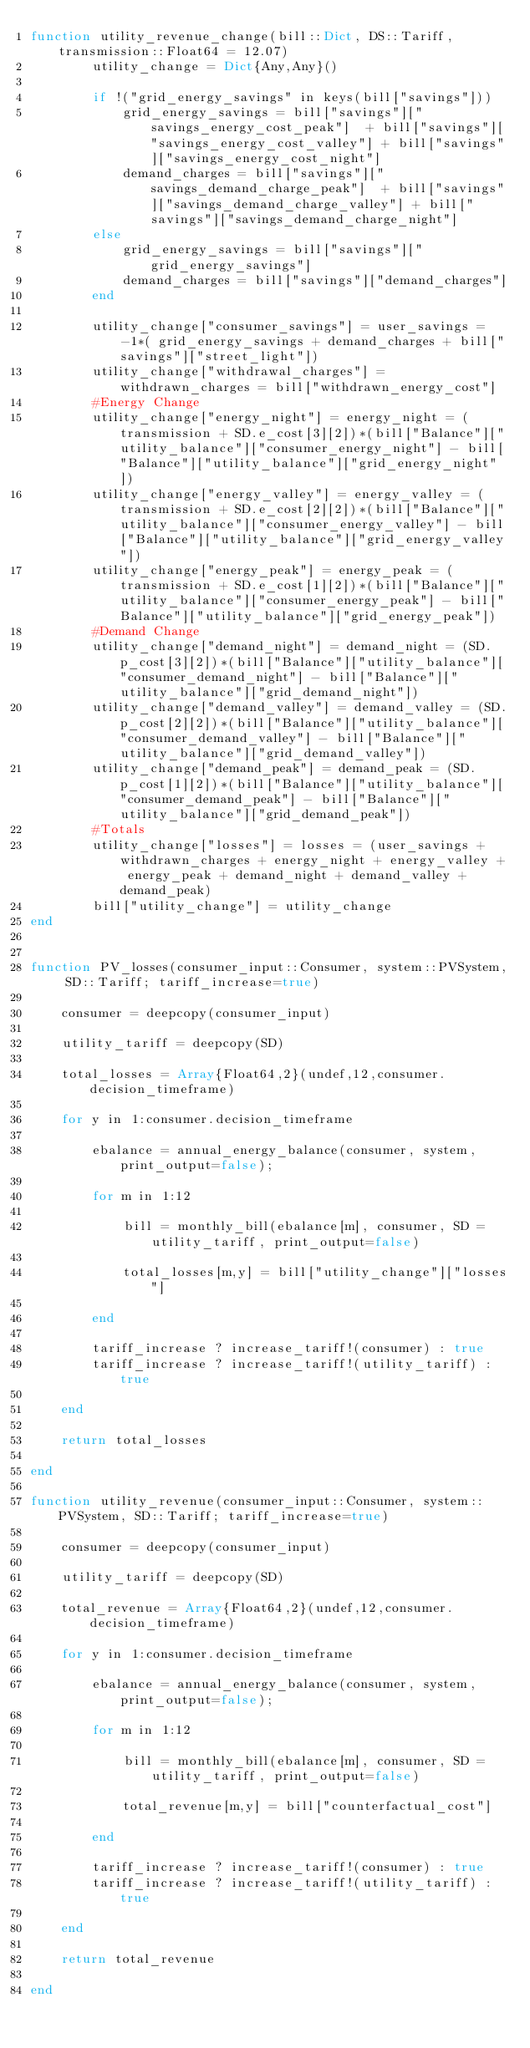<code> <loc_0><loc_0><loc_500><loc_500><_Julia_>function utility_revenue_change(bill::Dict, DS::Tariff, transmission::Float64 = 12.07)
        utility_change = Dict{Any,Any}()
        
		if !("grid_energy_savings" in keys(bill["savings"]))
			grid_energy_savings = bill["savings"]["savings_energy_cost_peak"]  + bill["savings"]["savings_energy_cost_valley"] + bill["savings"]["savings_energy_cost_night"]
		    demand_charges = bill["savings"]["savings_demand_charge_peak"]  + bill["savings"]["savings_demand_charge_valley"] + bill["savings"]["savings_demand_charge_night"]
		else
			grid_energy_savings = bill["savings"]["grid_energy_savings"]
			demand_charges = bill["savings"]["demand_charges"]
		end
		
		utility_change["consumer_savings"] = user_savings = -1*( grid_energy_savings + demand_charges + bill["savings"]["street_light"])
        utility_change["withdrawal_charges"] = withdrawn_charges = bill["withdrawn_energy_cost"]
        #Energy Change 
        utility_change["energy_night"] = energy_night = (transmission + SD.e_cost[3][2])*(bill["Balance"]["utility_balance"]["consumer_energy_night"] - bill["Balance"]["utility_balance"]["grid_energy_night"])
        utility_change["energy_valley"] = energy_valley = (transmission + SD.e_cost[2][2])*(bill["Balance"]["utility_balance"]["consumer_energy_valley"] - bill["Balance"]["utility_balance"]["grid_energy_valley"])
        utility_change["energy_peak"] = energy_peak = (transmission + SD.e_cost[1][2])*(bill["Balance"]["utility_balance"]["consumer_energy_peak"] - bill["Balance"]["utility_balance"]["grid_energy_peak"])
        #Demand Change 
        utility_change["demand_night"] = demand_night = (SD.p_cost[3][2])*(bill["Balance"]["utility_balance"]["consumer_demand_night"] - bill["Balance"]["utility_balance"]["grid_demand_night"])
        utility_change["demand_valley"] = demand_valley = (SD.p_cost[2][2])*(bill["Balance"]["utility_balance"]["consumer_demand_valley"] - bill["Balance"]["utility_balance"]["grid_demand_valley"])
        utility_change["demand_peak"] = demand_peak = (SD.p_cost[1][2])*(bill["Balance"]["utility_balance"]["consumer_demand_peak"] - bill["Balance"]["utility_balance"]["grid_demand_peak"])      
        #Totals
        utility_change["losses"] = losses = (user_savings + withdrawn_charges + energy_night + energy_valley + energy_peak + demand_night + demand_valley + demand_peak) 
        bill["utility_change"] = utility_change
end
	
	
function PV_losses(consumer_input::Consumer, system::PVSystem, SD::Tariff; tariff_increase=true)
    
    consumer = deepcopy(consumer_input)
    
	utility_tariff = deepcopy(SD)	
		
	total_losses = Array{Float64,2}(undef,12,consumer.decision_timeframe)
    
    for y in 1:consumer.decision_timeframe
                
        ebalance = annual_energy_balance(consumer, system, print_output=false);
        
        for m in 1:12

            bill = monthly_bill(ebalance[m], consumer, SD = utility_tariff, print_output=false)

            total_losses[m,y] = bill["utility_change"]["losses"]

        end
        
        tariff_increase ? increase_tariff!(consumer) : true
		tariff_increase ? increase_tariff!(utility_tariff) : true	
        
    end

    return total_losses
        
end
	
function utility_revenue(consumer_input::Consumer, system::PVSystem, SD::Tariff; tariff_increase=true)
    
    consumer = deepcopy(consumer_input)
    
	utility_tariff = deepcopy(SD)	
		
	total_revenue = Array{Float64,2}(undef,12,consumer.decision_timeframe)
    
    for y in 1:consumer.decision_timeframe
                
        ebalance = annual_energy_balance(consumer, system, print_output=false);
        
        for m in 1:12

            bill = monthly_bill(ebalance[m], consumer, SD = utility_tariff, print_output=false)

            total_revenue[m,y] = bill["counterfactual_cost"]

        end
        
        tariff_increase ? increase_tariff!(consumer) : true
		tariff_increase ? increase_tariff!(utility_tariff) : true	
        
    end

    return total_revenue
        
end	</code> 